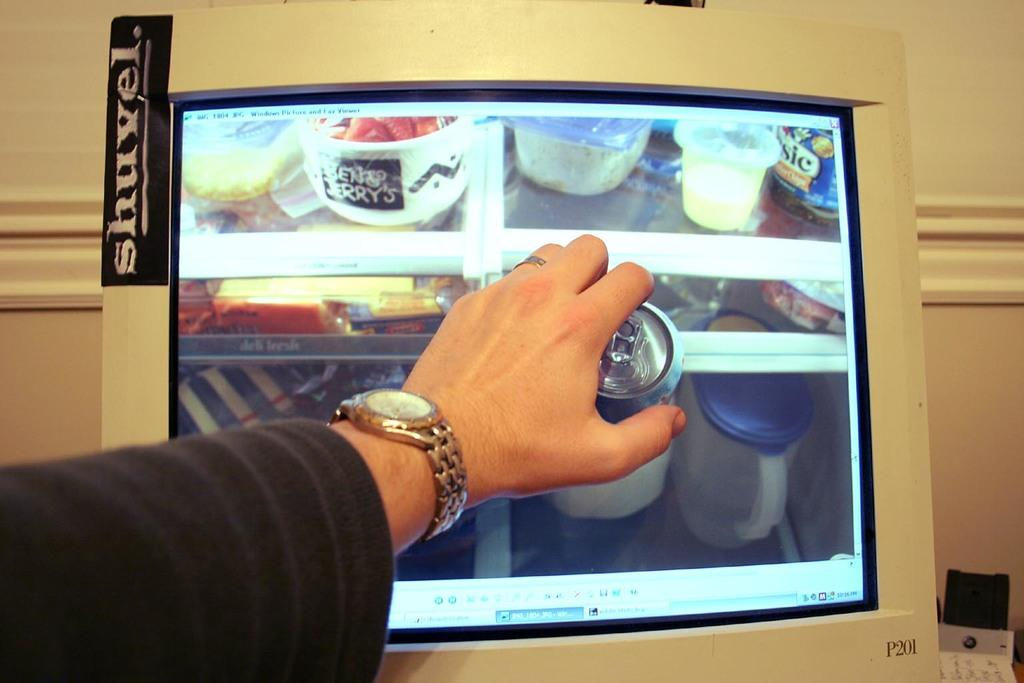<image>
Render a clear and concise summary of the photo. a person's arm with a lenny's sign next to it 